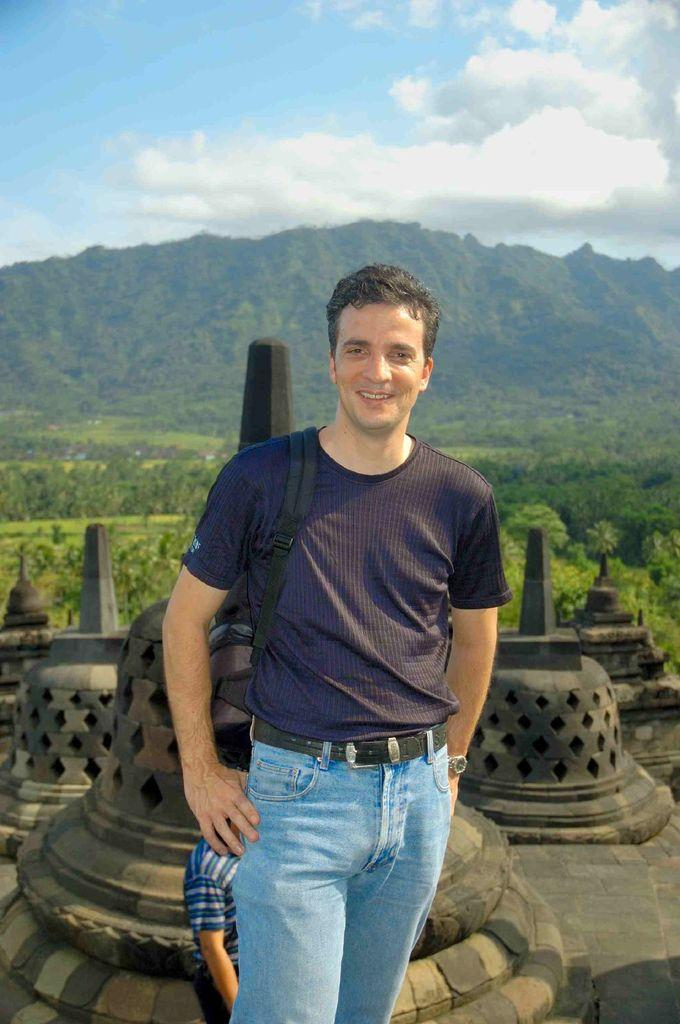Who is present in the image? There is a man in the image. What is the man wearing? The man is wearing a blue T-shirt and blue jeans. What can be seen in the background of the image? There is a mountain, plants, trees, and clouds in the sky in the background of the image. What type of tomatoes can be seen on the sheet in the bedroom in the image? There is no mention of tomatoes, a sheet, or a bedroom in the image; it features a man wearing a blue T-shirt and blue jeans with a mountain, plants, trees, and clouds in the background. 